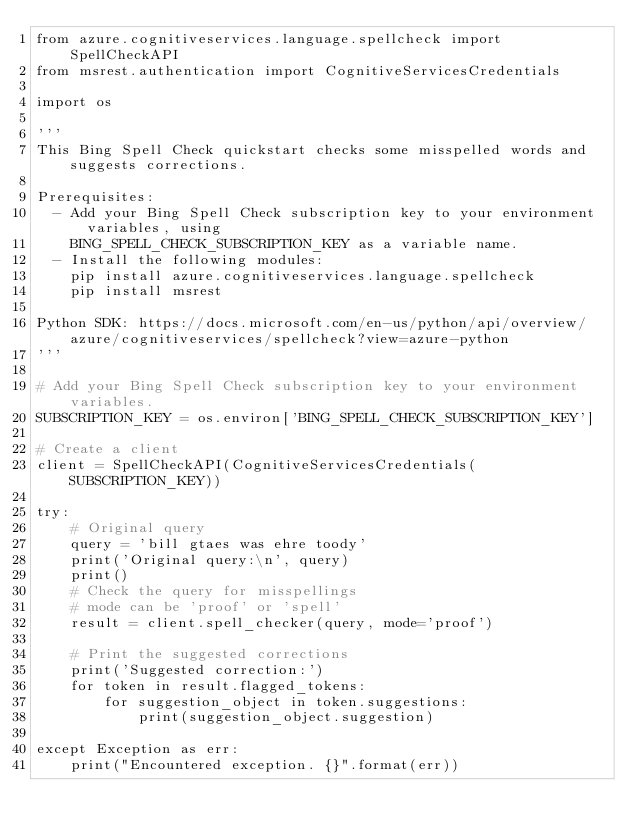<code> <loc_0><loc_0><loc_500><loc_500><_Python_>from azure.cognitiveservices.language.spellcheck import SpellCheckAPI
from msrest.authentication import CognitiveServicesCredentials

import os

'''
This Bing Spell Check quickstart checks some misspelled words and suggests corrections.

Prerequisites:
  - Add your Bing Spell Check subscription key to your environment variables, using
    BING_SPELL_CHECK_SUBSCRIPTION_KEY as a variable name.
  - Install the following modules:
    pip install azure.cognitiveservices.language.spellcheck
    pip install msrest

Python SDK: https://docs.microsoft.com/en-us/python/api/overview/azure/cognitiveservices/spellcheck?view=azure-python
'''

# Add your Bing Spell Check subscription key to your environment variables.
SUBSCRIPTION_KEY = os.environ['BING_SPELL_CHECK_SUBSCRIPTION_KEY']

# Create a client
client = SpellCheckAPI(CognitiveServicesCredentials(SUBSCRIPTION_KEY))

try:
    # Original query
    query = 'bill gtaes was ehre toody'
    print('Original query:\n', query)
    print()
    # Check the query for misspellings
    # mode can be 'proof' or 'spell'
    result = client.spell_checker(query, mode='proof')

    # Print the suggested corrections
    print('Suggested correction:')
    for token in result.flagged_tokens:
        for suggestion_object in token.suggestions:
            print(suggestion_object.suggestion)

except Exception as err:
    print("Encountered exception. {}".format(err))
</code> 